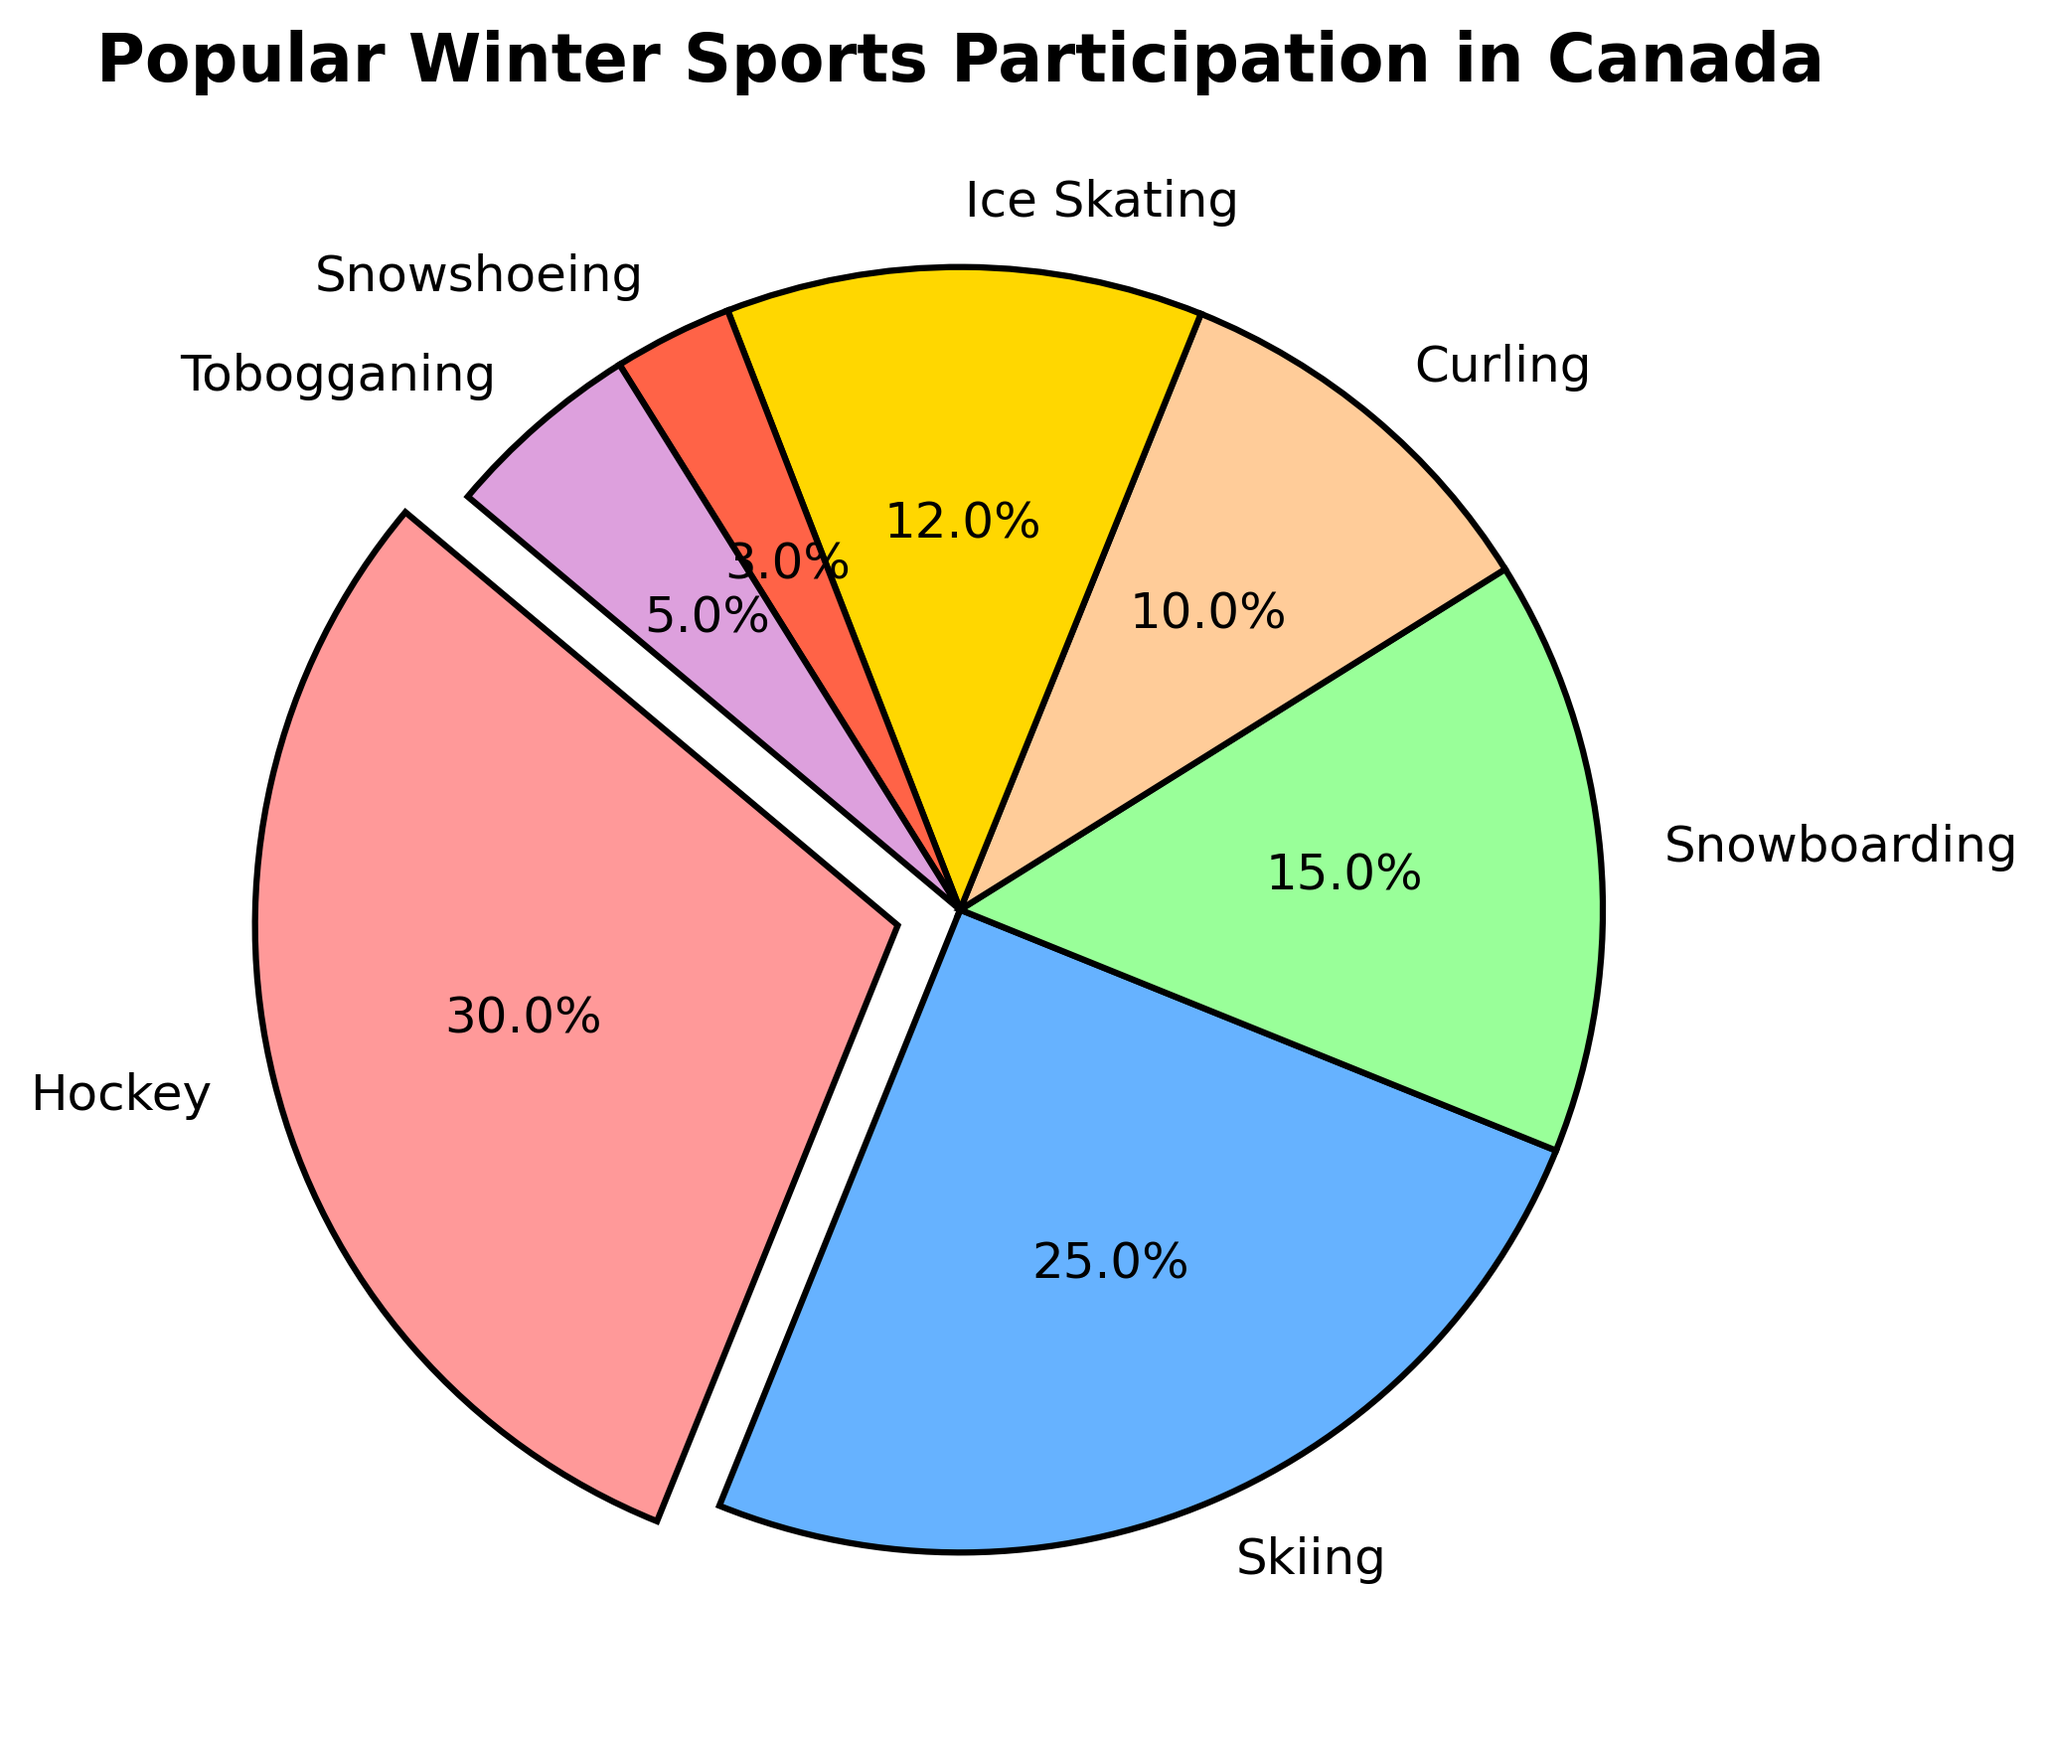Which winter sport has the highest participation percentage? The pie chart shows the participation percentages for different winter sports. The sport with the largest slice and an exploded section is Hockey.
Answer: Hockey What is the total participation percentage of Skiing, Snowboarding, and Ice Skating? To find the total participation percentage, add the individual percentages for Skiing (25%), Snowboarding (15%), and Ice Skating (12%). 25 + 15 + 12 = 52%.
Answer: 52% Which sport has a higher participation rate, Curling or Tobogganing? Comparing the slices for Curling (10%) and Tobogganing (5%) from the pie chart shows that Curling has a higher participation rate.
Answer: Curling What is the difference in participation percentage between the sport with the highest and lowest participation? The highest participation percentage is Hockey (30%) and the lowest is Snowshoeing (3%). The difference is 30 - 3 = 27%.
Answer: 27% What color represents Snowboarding in the pie chart? The legend or the slice's color representing Snowboarding is primarily used to answer this. The pie chart shows Snowboarding in green.
Answer: Green Are there more people participating in Skiing or Snowboarding? Refer to the participation percentages of Skiing (25%) and Snowboarding (15%) from the pie chart, which shows that more people participate in Skiing.
Answer: Skiing What is the combined participation percentage of all the sports other than Hockey? To find the combined percentage of all sports other than Hockey, add Skiing (25%), Snowboarding (15%), Curling (10%), Ice Skating (12%), Snowshoeing (3%), and Tobogganing (5%). This totals to 25 + 15 + 10 + 12 + 3 + 5 = 70%.
Answer: 70% Which sport is represented by the smallest slice in the pie chart? The smallest slice in the pie chart, corresponding to the lowest participation percentage, is for Snowshoeing (3%).
Answer: Snowshoeing How much larger is the participation percentage for Ice Skating compared to Snowshoeing? Ice Skating has a participation percentage of 12%, and Snowshoeing has 3%. The difference is 12 - 3 = 9%.
Answer: 9% 